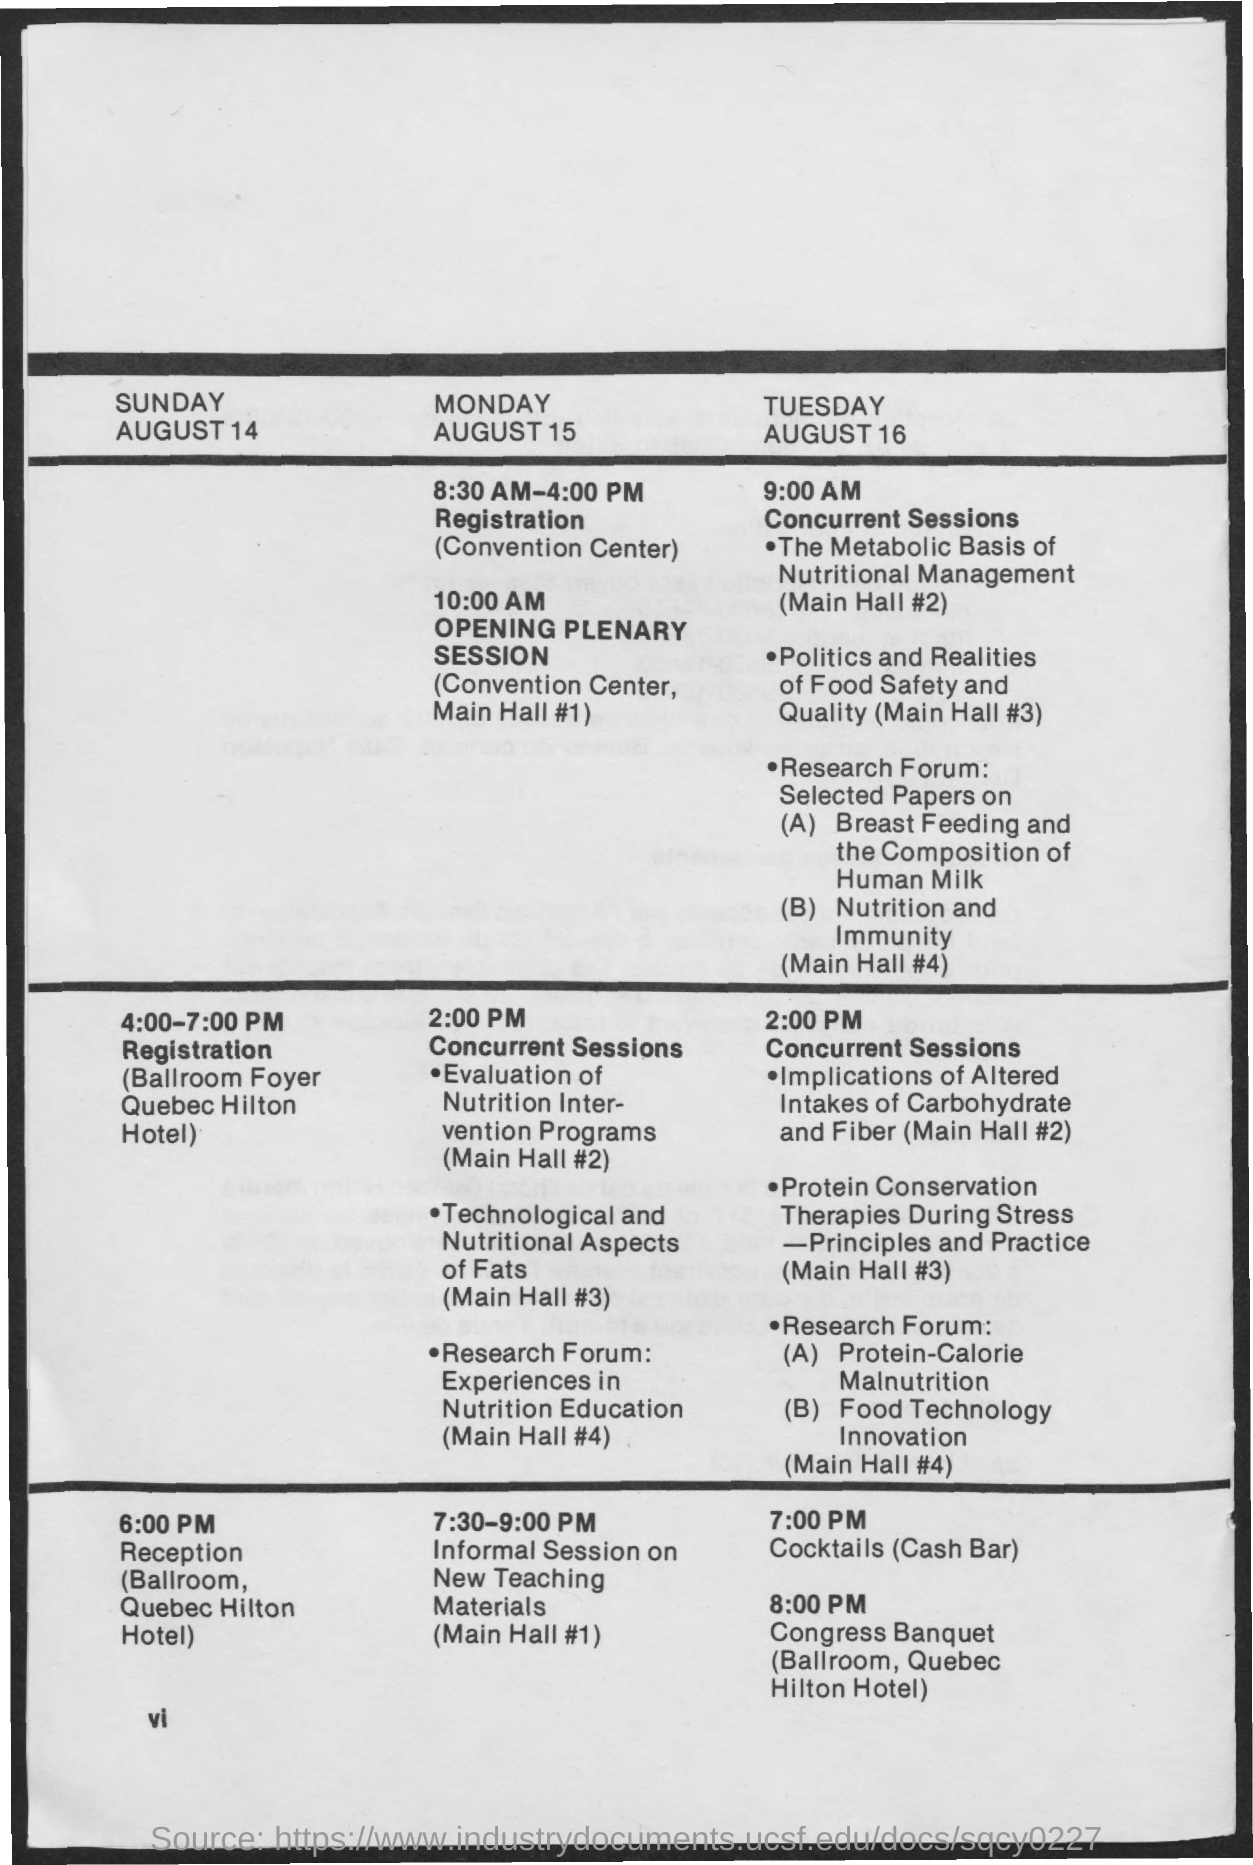What is timing for registration on monday, august 15?
Offer a terse response. 8:30 AM-4:00 PM. What is timing for registration on sunday, august 14?
Your answer should be compact. 4:00-7:00 PM. What is the timing for concurrent sessions on monday, august 15?
Your answer should be compact. 2:00 PM. 